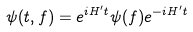Convert formula to latex. <formula><loc_0><loc_0><loc_500><loc_500>\psi ( t , f ) = e ^ { i H ^ { \prime } t } \psi ( f ) e ^ { - i H ^ { \prime } t }</formula> 